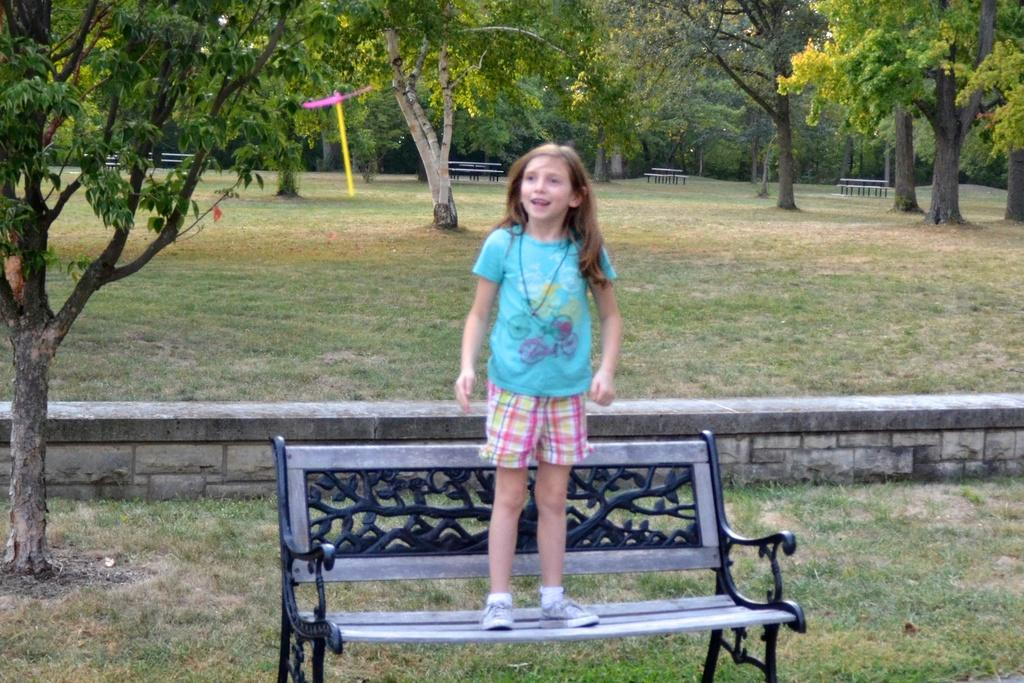Who is the main subject in the image? There is a girl in the image. What is the girl doing in the image? The girl is standing on a bench. What can be seen in the background of the image? There are trees visible in the background of the image. What type of fruit is the girl holding in the image? There is no fruit present in the image. How many cows can be seen grazing in the background of the image? There are no cows visible in the image; only trees are present in the background. 